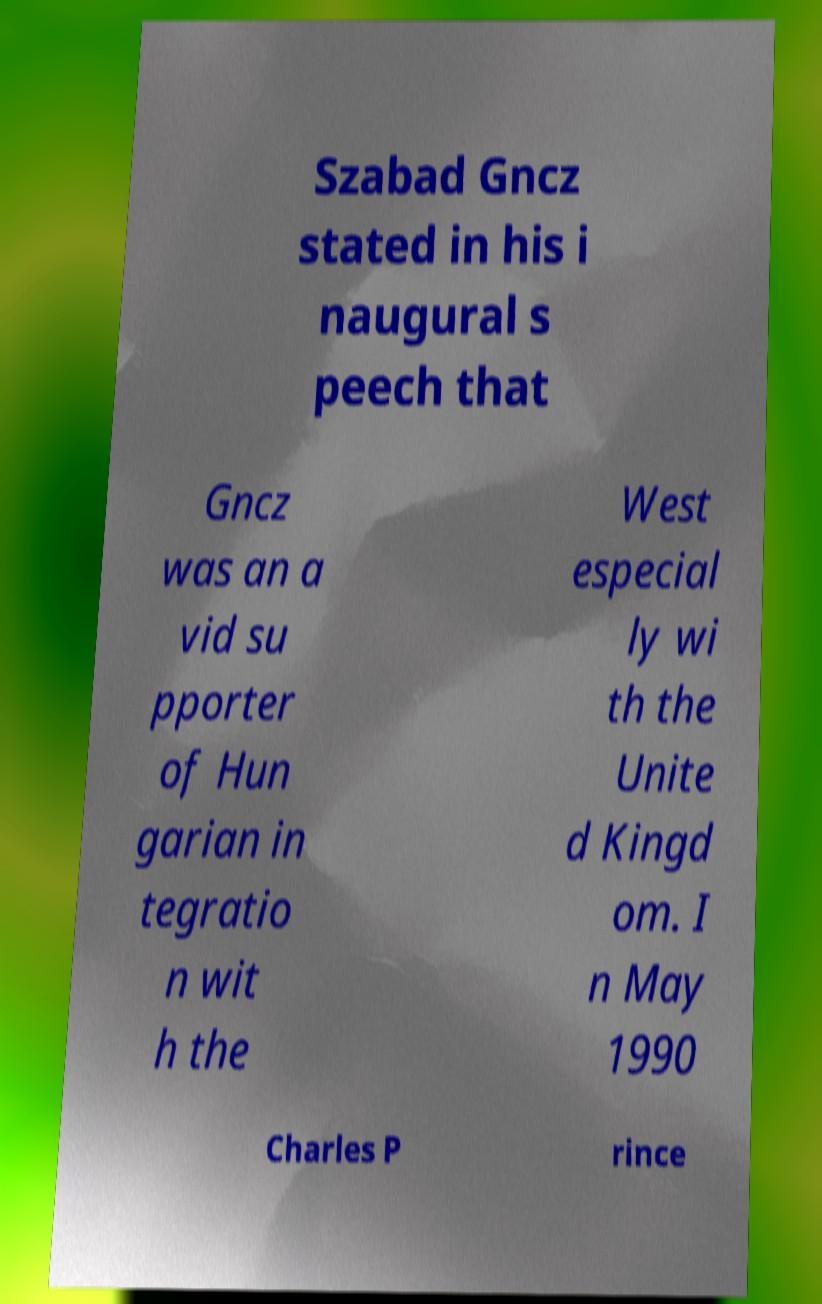Can you read and provide the text displayed in the image?This photo seems to have some interesting text. Can you extract and type it out for me? Szabad Gncz stated in his i naugural s peech that Gncz was an a vid su pporter of Hun garian in tegratio n wit h the West especial ly wi th the Unite d Kingd om. I n May 1990 Charles P rince 